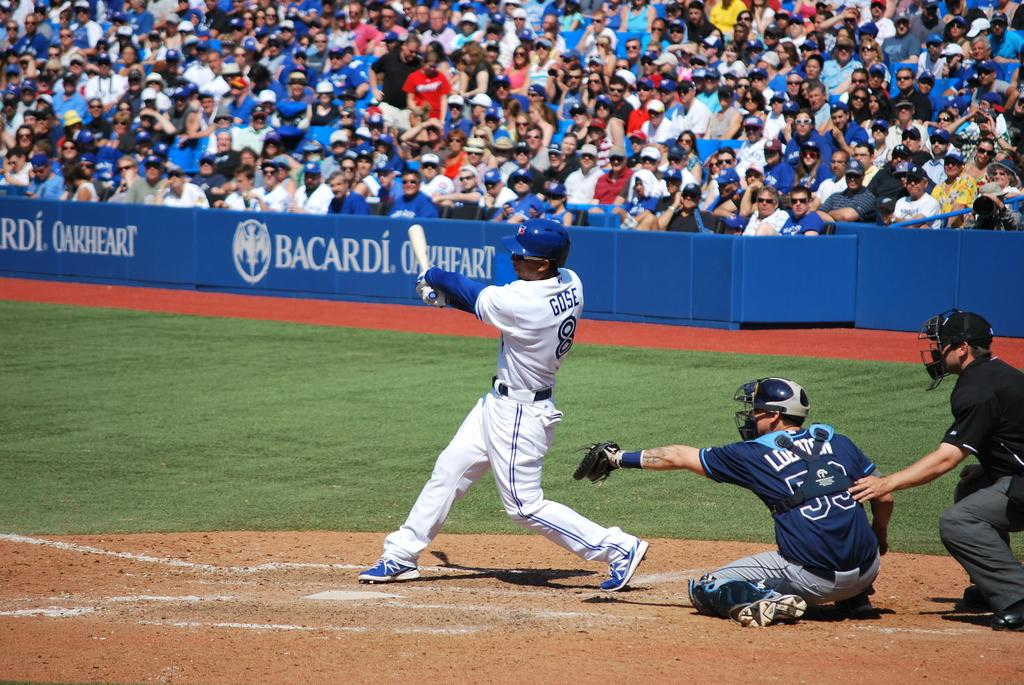<image>
Offer a succinct explanation of the picture presented. Man named Gose batting the baseball into the air. 